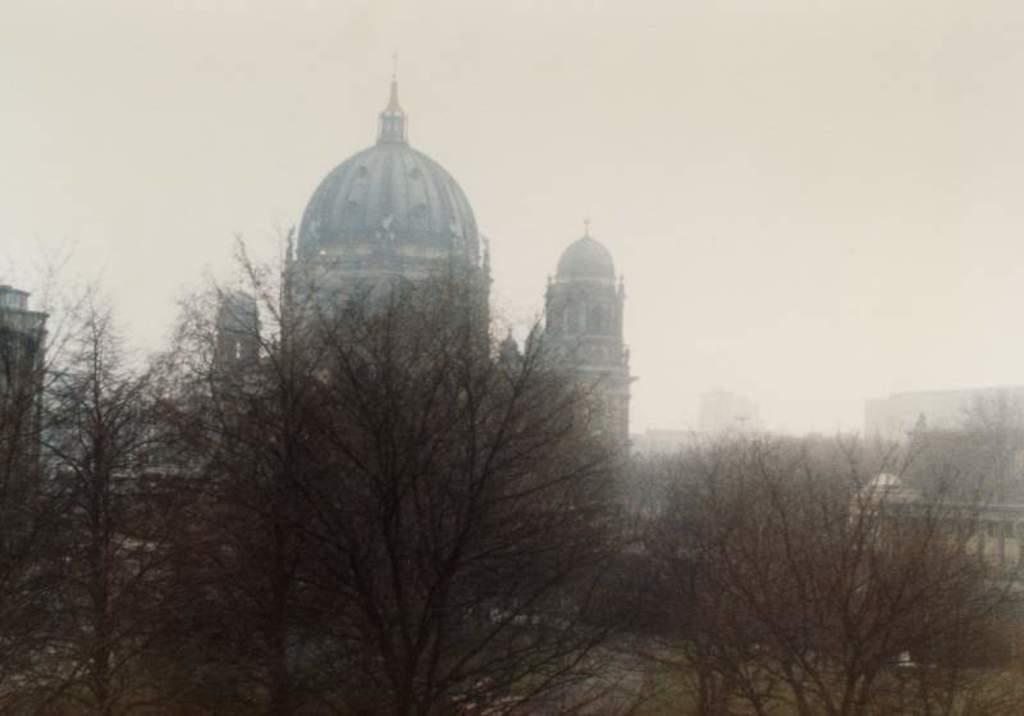What type of vegetation is in the front of the image? There are trees in the front of the image. What type of structures can be seen in the background of the image? There are buildings in the background of the image. What is visible at the top of the image? The sky is visible at the top of the image. Can you see a bear with a chin in the image? There is no bear or chin present in the image. How many toads are sitting on the trees in the image? There are no toads present in the image; it features trees and buildings. 